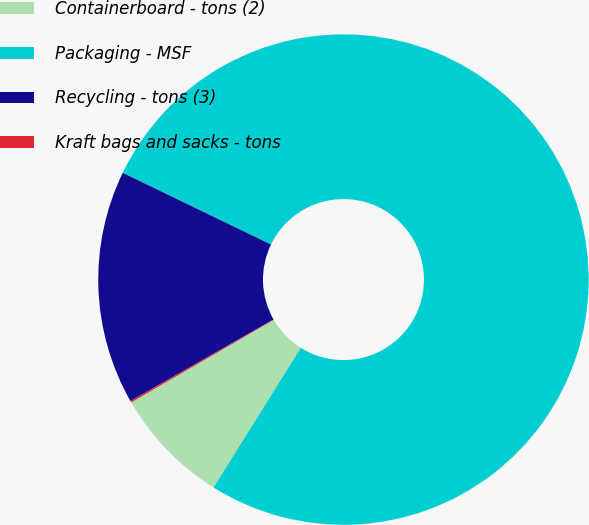Convert chart to OTSL. <chart><loc_0><loc_0><loc_500><loc_500><pie_chart><fcel>Containerboard - tons (2)<fcel>Packaging - MSF<fcel>Recycling - tons (3)<fcel>Kraft bags and sacks - tons<nl><fcel>7.76%<fcel>76.72%<fcel>15.42%<fcel>0.1%<nl></chart> 